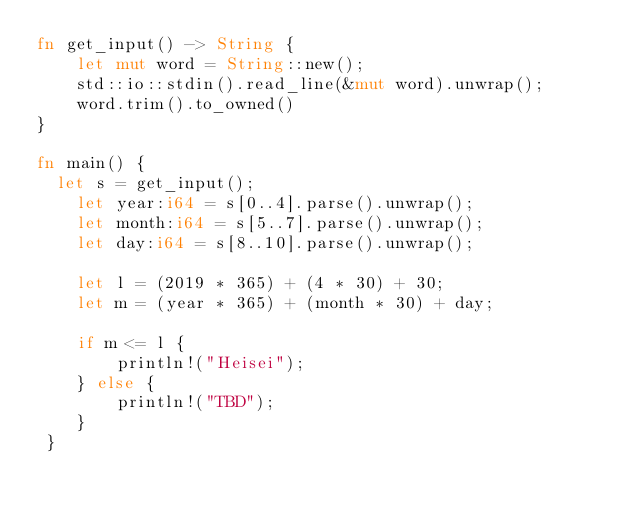Convert code to text. <code><loc_0><loc_0><loc_500><loc_500><_Rust_>fn get_input() -> String {
    let mut word = String::new();
    std::io::stdin().read_line(&mut word).unwrap();
    word.trim().to_owned()
}

fn main() {
	let s = get_input();
    let year:i64 = s[0..4].parse().unwrap();
    let month:i64 = s[5..7].parse().unwrap();
    let day:i64 = s[8..10].parse().unwrap();

    let l = (2019 * 365) + (4 * 30) + 30;
    let m = (year * 365) + (month * 30) + day;
    
    if m <= l {
        println!("Heisei");
    } else {
        println!("TBD");
    }
 }</code> 